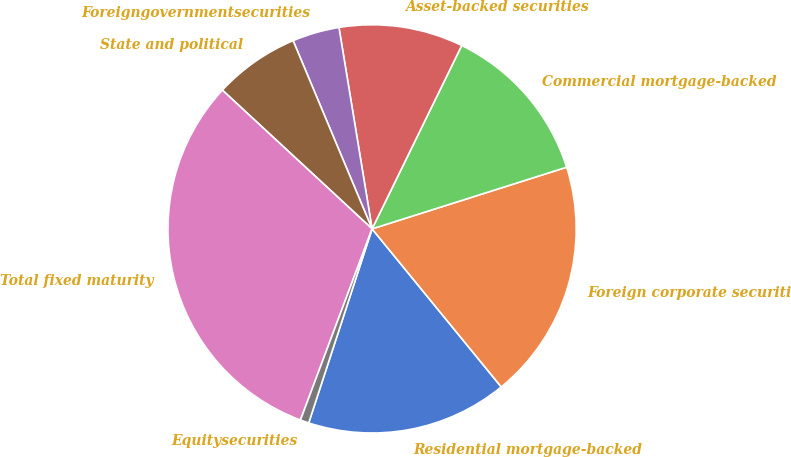Convert chart to OTSL. <chart><loc_0><loc_0><loc_500><loc_500><pie_chart><fcel>Residential mortgage-backed<fcel>Foreign corporate securities<fcel>Commercial mortgage-backed<fcel>Asset-backed securities<fcel>Foreigngovernmentsecurities<fcel>State and political<fcel>Total fixed maturity<fcel>Equitysecurities<nl><fcel>15.93%<fcel>18.98%<fcel>12.88%<fcel>9.83%<fcel>3.73%<fcel>6.78%<fcel>31.19%<fcel>0.68%<nl></chart> 